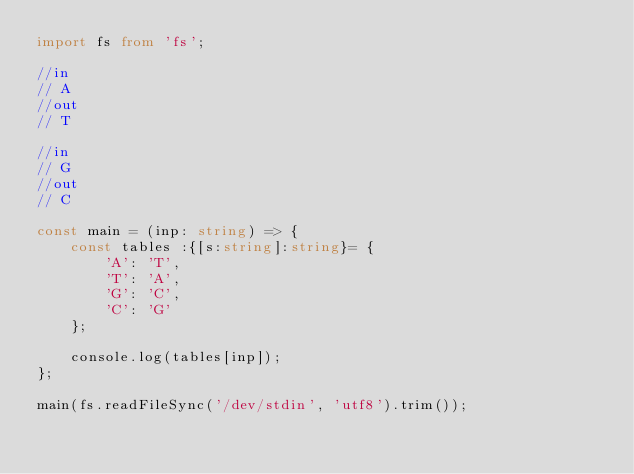<code> <loc_0><loc_0><loc_500><loc_500><_TypeScript_>import fs from 'fs';

//in
// A
//out
// T

//in
// G
//out
// C

const main = (inp: string) => {
    const tables :{[s:string]:string}= {
        'A': 'T',
        'T': 'A',
        'G': 'C',
        'C': 'G'
    };

    console.log(tables[inp]);
};

main(fs.readFileSync('/dev/stdin', 'utf8').trim());
</code> 